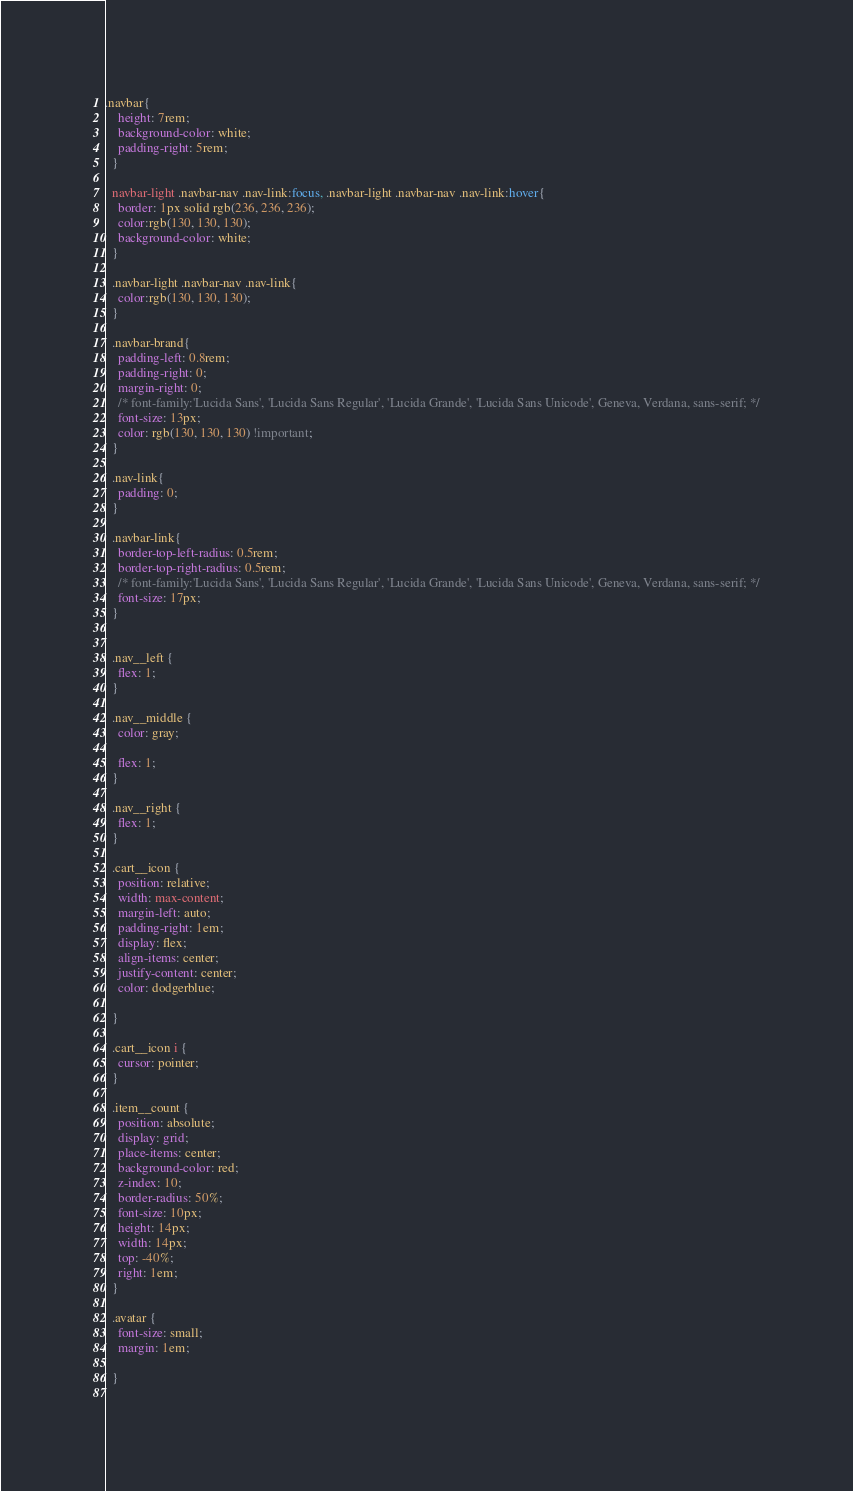Convert code to text. <code><loc_0><loc_0><loc_500><loc_500><_CSS_>.navbar{
    height: 7rem;
    background-color: white;
    padding-right: 5rem;
  }
  
  navbar-light .navbar-nav .nav-link:focus, .navbar-light .navbar-nav .nav-link:hover{
    border: 1px solid rgb(236, 236, 236);
    color:rgb(130, 130, 130);
    background-color: white;
  }
  
  .navbar-light .navbar-nav .nav-link{
    color:rgb(130, 130, 130);
  }
  
  .navbar-brand{
    padding-left: 0.8rem;
    padding-right: 0;
    margin-right: 0;
    /* font-family:'Lucida Sans', 'Lucida Sans Regular', 'Lucida Grande', 'Lucida Sans Unicode', Geneva, Verdana, sans-serif; */
    font-size: 13px;
    color: rgb(130, 130, 130) !important;
  }
  
  .nav-link{
    padding: 0;
  }
  
  .navbar-link{
    border-top-left-radius: 0.5rem;
    border-top-right-radius: 0.5rem;
    /* font-family:'Lucida Sans', 'Lucida Sans Regular', 'Lucida Grande', 'Lucida Sans Unicode', Geneva, Verdana, sans-serif; */
    font-size: 17px;
  }

    
  .nav__left {
    flex: 1;
  }
  
  .nav__middle {
    color: gray;
  
    flex: 1;
  }

  .nav__right {
    flex: 1;
  }
  
  .cart__icon {
    position: relative;
    width: max-content;
    margin-left: auto;
    padding-right: 1em;
    display: flex;
    align-items: center;
    justify-content: center;
    color: dodgerblue;

  }
  
  .cart__icon i {
    cursor: pointer;
  }
  
  .item__count {
    position: absolute;
    display: grid;
    place-items: center;
    background-color: red;
    z-index: 10;
    border-radius: 50%;
    font-size: 10px;
    height: 14px;
    width: 14px;
    top: -40%;
    right: 1em;
  }

  .avatar {
    font-size: small;
    margin: 1em;

  }
  </code> 